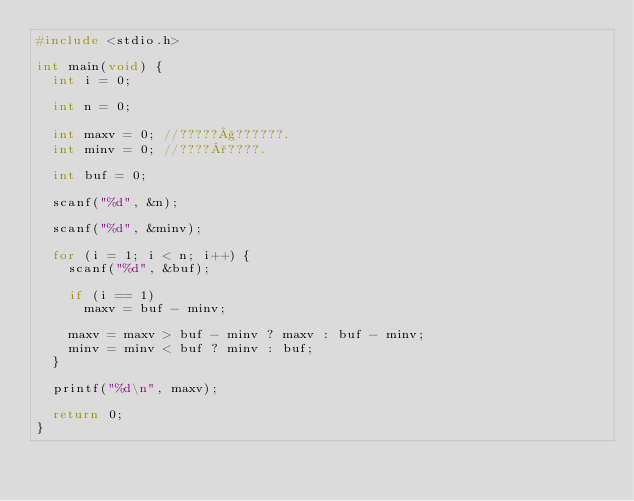Convert code to text. <code><loc_0><loc_0><loc_500><loc_500><_C_>#include <stdio.h>

int main(void) {
	int i = 0;

	int n = 0;

	int maxv = 0;	//?????§??????.
	int minv = 0;	//????°????.

	int buf = 0;

	scanf("%d", &n);

	scanf("%d", &minv);

	for (i = 1; i < n; i++) {
		scanf("%d", &buf);

		if (i == 1)
			maxv = buf - minv;

		maxv = maxv > buf - minv ? maxv : buf - minv;
		minv = minv < buf ? minv : buf;
	}

	printf("%d\n", maxv);

	return 0;
}</code> 